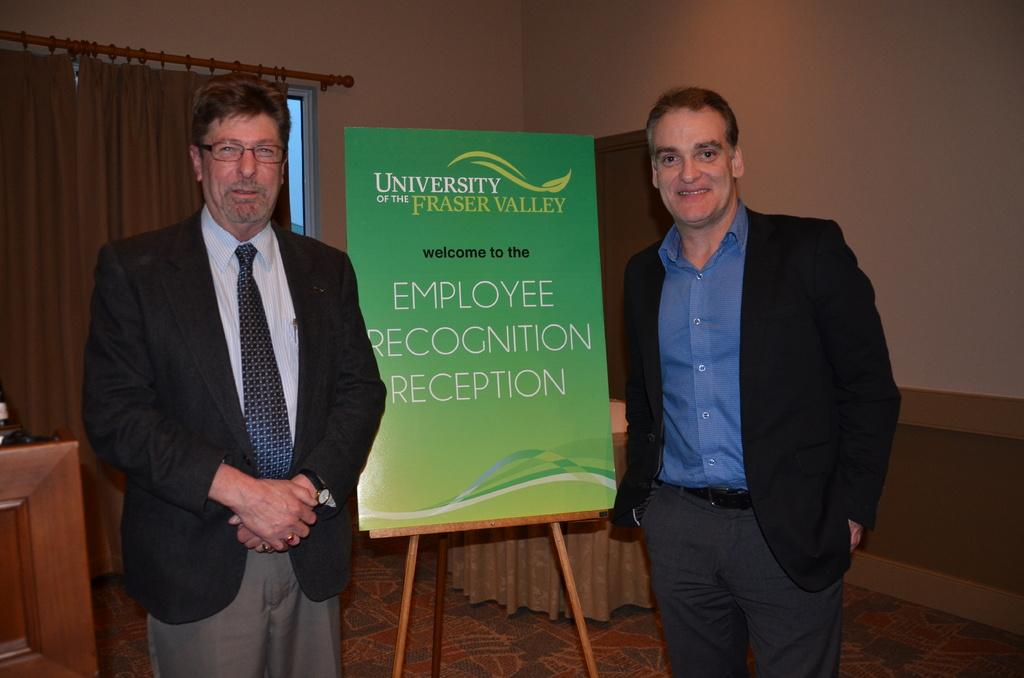How many people are present in the image? There are two people standing in the image. Where are the people standing? The people are standing on the floor. What can be seen in the background of the image? There is a stand with a board and a wall with a window in the background. Is there any window treatment present in the image? Yes, there is a curtain associated with the window. What other unspecified things can be seen in the background? There are other unspecified things visible in the background. What type of liquid is being used by the people in the image? There is no liquid present in the image; the people are simply standing on the floor. 